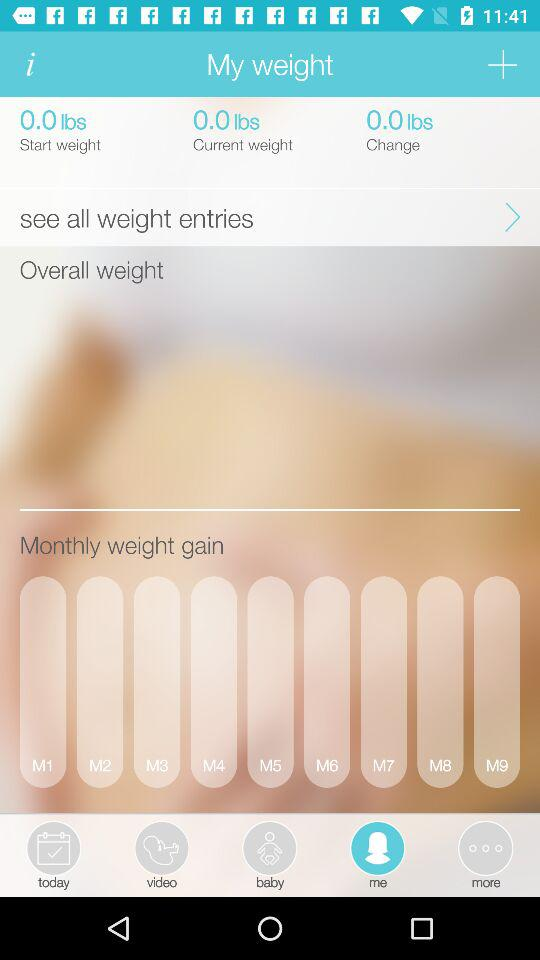What is the unit of weight? The unit of weight is lbs. 